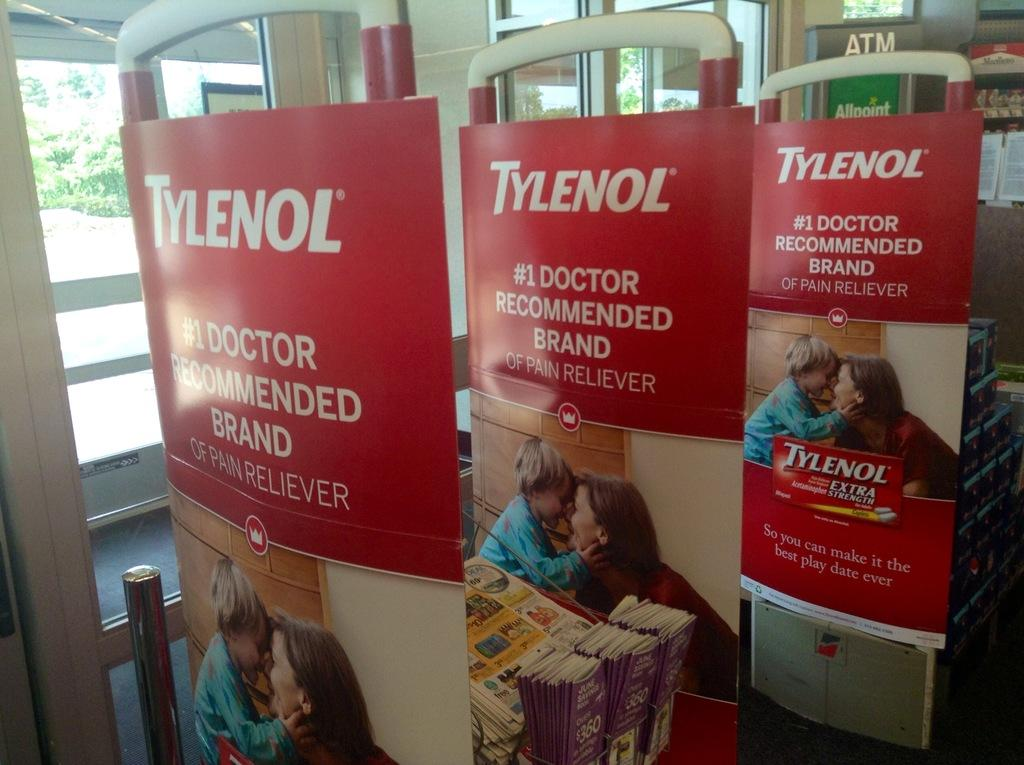Provide a one-sentence caption for the provided image. Three adverts in red for Tylenol, the painkiller. 